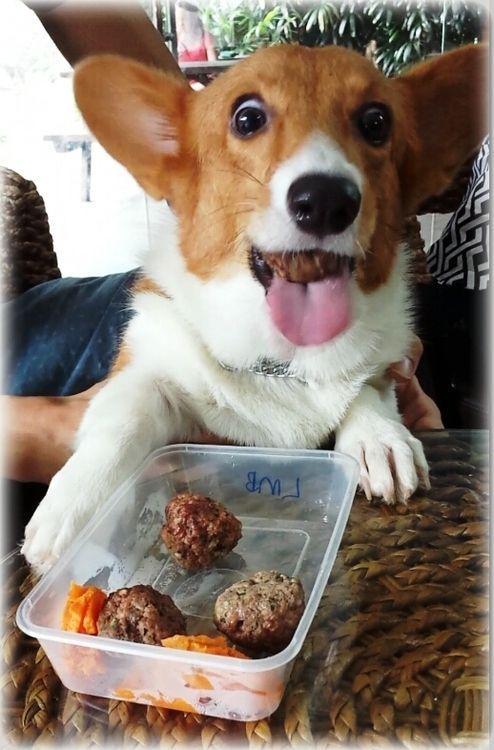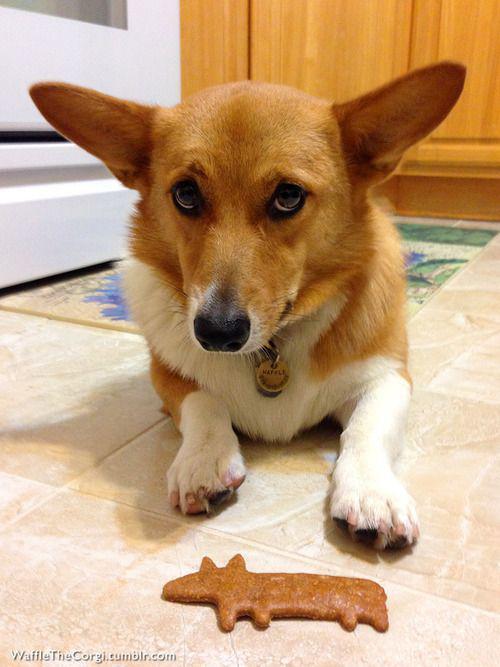The first image is the image on the left, the second image is the image on the right. Evaluate the accuracy of this statement regarding the images: "At least one Corgi is behind a container of food.". Is it true? Answer yes or no. Yes. The first image is the image on the left, the second image is the image on the right. Examine the images to the left and right. Is the description "There us food in front of a single dog in at least one of the images." accurate? Answer yes or no. Yes. 